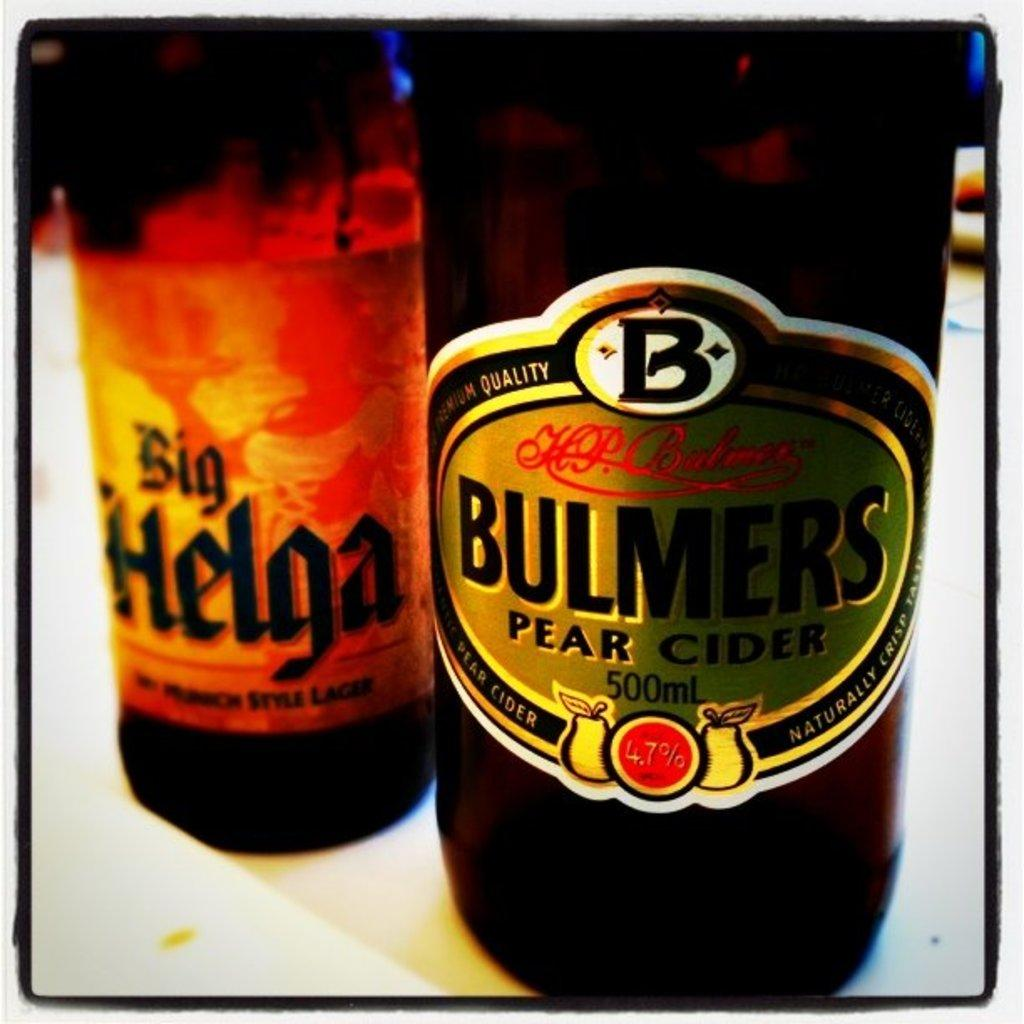<image>
Give a short and clear explanation of the subsequent image. Bulmers Pear Cider is the brand shown on the label of this bottle. 